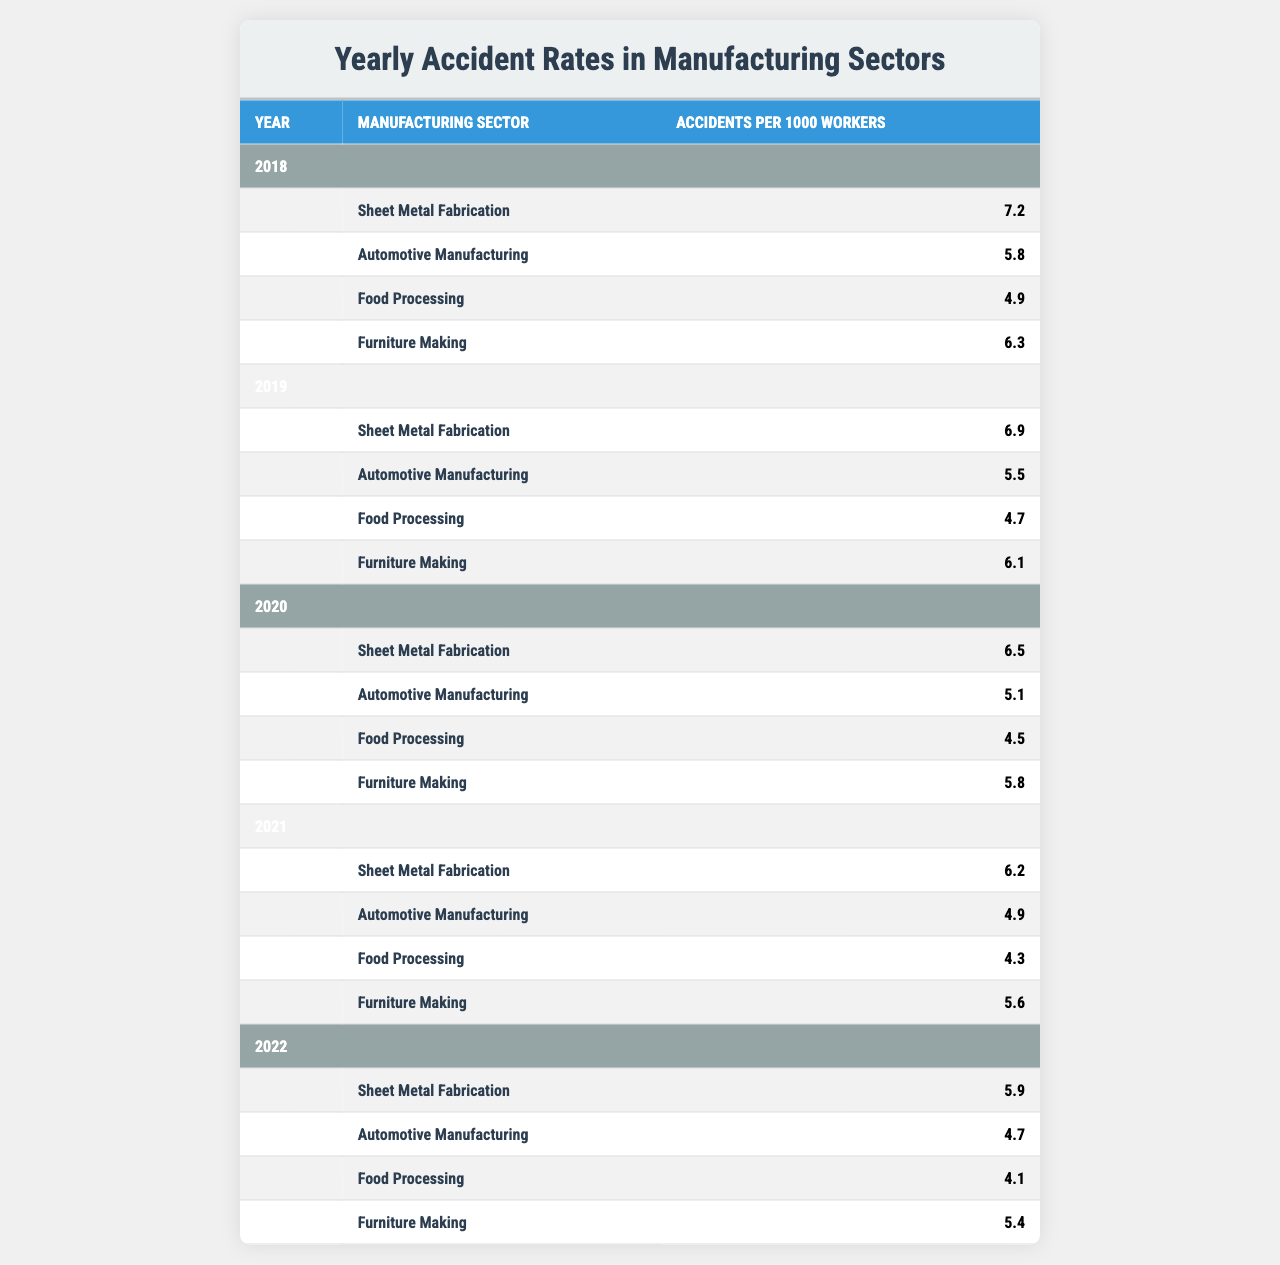What was the accident rate in Sheet Metal Fabrication in 2021? The table shows that in 2021, the accident rate for Sheet Metal Fabrication was 6.2 accidents per 1000 workers.
Answer: 6.2 Which manufacturing sector had the highest accident rate in 2018? In the year 2018, the highest accident rate was in Sheet Metal Fabrication at 7.2 accidents per 1000 workers.
Answer: Sheet Metal Fabrication What is the trend of accident rates in the Food Processing sector from 2018 to 2022? The rates decreased from 4.9 in 2018 to 4.1 in 2022. This shows a declining trend over the five-year period.
Answer: Decreasing What is the average accident rate for Automotive Manufacturing from 2018 to 2022? The accident rates for Automotive Manufacturing over these years are 5.8, 5.5, 5.1, 4.9, and 4.7. Adding them gives 27.0, and dividing by 5 results in an average of 5.4.
Answer: 5.4 Did the accident rates in Furniture Making improve from 2018 to 2022? The rates in Furniture Making were 6.3 in 2018 and dropped to 5.4 in 2022, indicating an improvement.
Answer: Yes What was the change in accident rates for Sheet Metal Fabrication from 2018 to 2022? The rate in 2018 was 7.2 and decreased to 5.9 in 2022. The change is 7.2 - 5.9 = 1.3, which means it decreased by 1.3.
Answer: Decreased by 1.3 Which sector had the lowest accident rate in 2020? The lowest accident rate in 2020 was in Food Processing at 4.5 accidents per 1000 workers.
Answer: Food Processing What is the difference in accident rates between the highest and lowest sectors in 2021? In 2021, the highest was Sheet Metal Fabrication at 6.2 and the lowest was Food Processing at 4.3. The difference is 6.2 - 4.3 = 1.9.
Answer: 1.9 Which manufacturing sector consistently had a lower accident rate than 5.0 every year from 2018 to 2022? Food Processing had rates below 5.0 in 2021 (4.3), 2022 (4.1), 2019 (4.7), and 2020 (4.5), and it was close in 2018 (4.9).
Answer: Food Processing In which year was the accident rate in Furniture Making the lowest? Looking at the table, the lowest rate in Furniture Making occurred in 2022, with a rate of 5.4.
Answer: 2022 What was the accident rate change for Automotive Manufacturing from 2019 to 2020? The rate was 5.5 in 2019 and dropped to 5.1 in 2020, showing a change of 5.5 - 5.1 = 0.4, which means it decreased.
Answer: Decreased by 0.4 